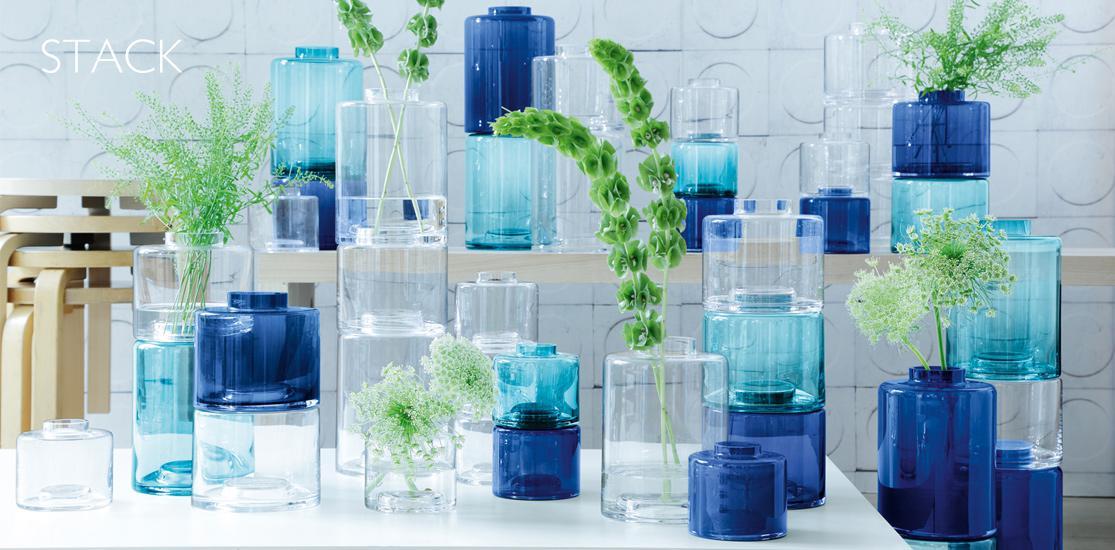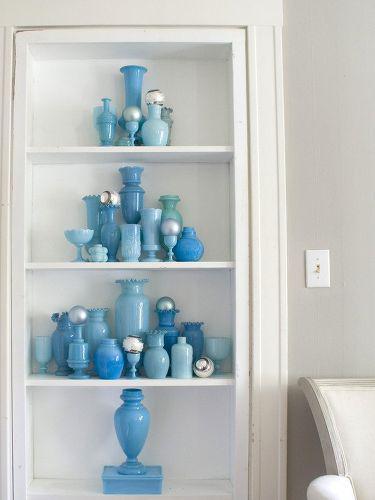The first image is the image on the left, the second image is the image on the right. Examine the images to the left and right. Is the description "An image shows vases with bold horizontal bands of color." accurate? Answer yes or no. No. 